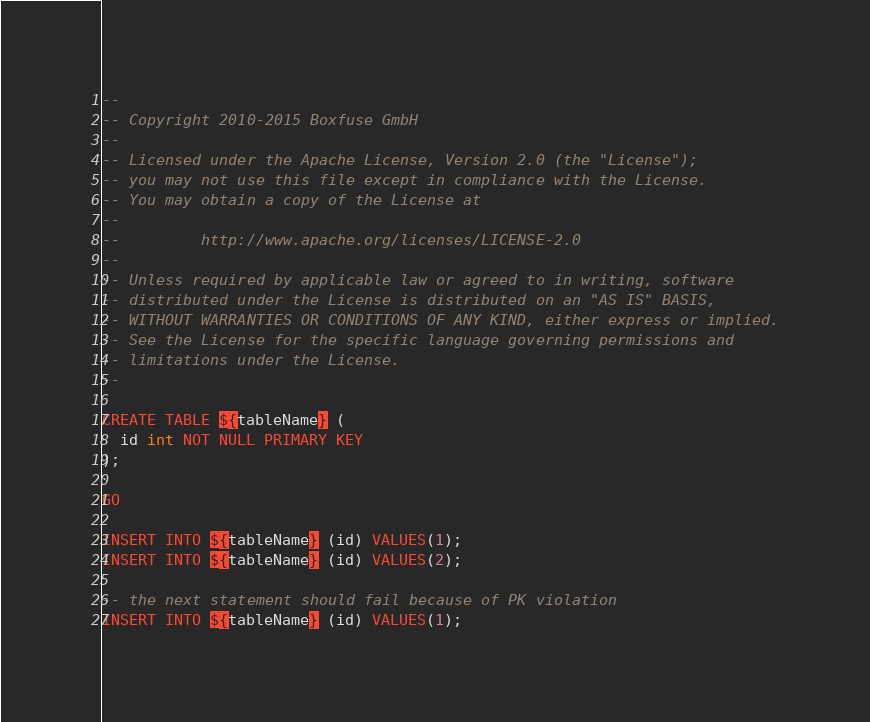<code> <loc_0><loc_0><loc_500><loc_500><_SQL_>--
-- Copyright 2010-2015 Boxfuse GmbH
--
-- Licensed under the Apache License, Version 2.0 (the "License");
-- you may not use this file except in compliance with the License.
-- You may obtain a copy of the License at
--
--         http://www.apache.org/licenses/LICENSE-2.0
--
-- Unless required by applicable law or agreed to in writing, software
-- distributed under the License is distributed on an "AS IS" BASIS,
-- WITHOUT WARRANTIES OR CONDITIONS OF ANY KIND, either express or implied.
-- See the License for the specific language governing permissions and
-- limitations under the License.
--

CREATE TABLE ${tableName} (
  id int NOT NULL PRIMARY KEY
);

GO

INSERT INTO ${tableName} (id) VALUES(1);
INSERT INTO ${tableName} (id) VALUES(2);

-- the next statement should fail because of PK violation
INSERT INTO ${tableName} (id) VALUES(1);

</code> 